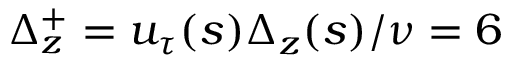Convert formula to latex. <formula><loc_0><loc_0><loc_500><loc_500>\Delta _ { z } ^ { + } = u _ { \tau } ( s ) \Delta _ { z } ( s ) / \nu = 6</formula> 